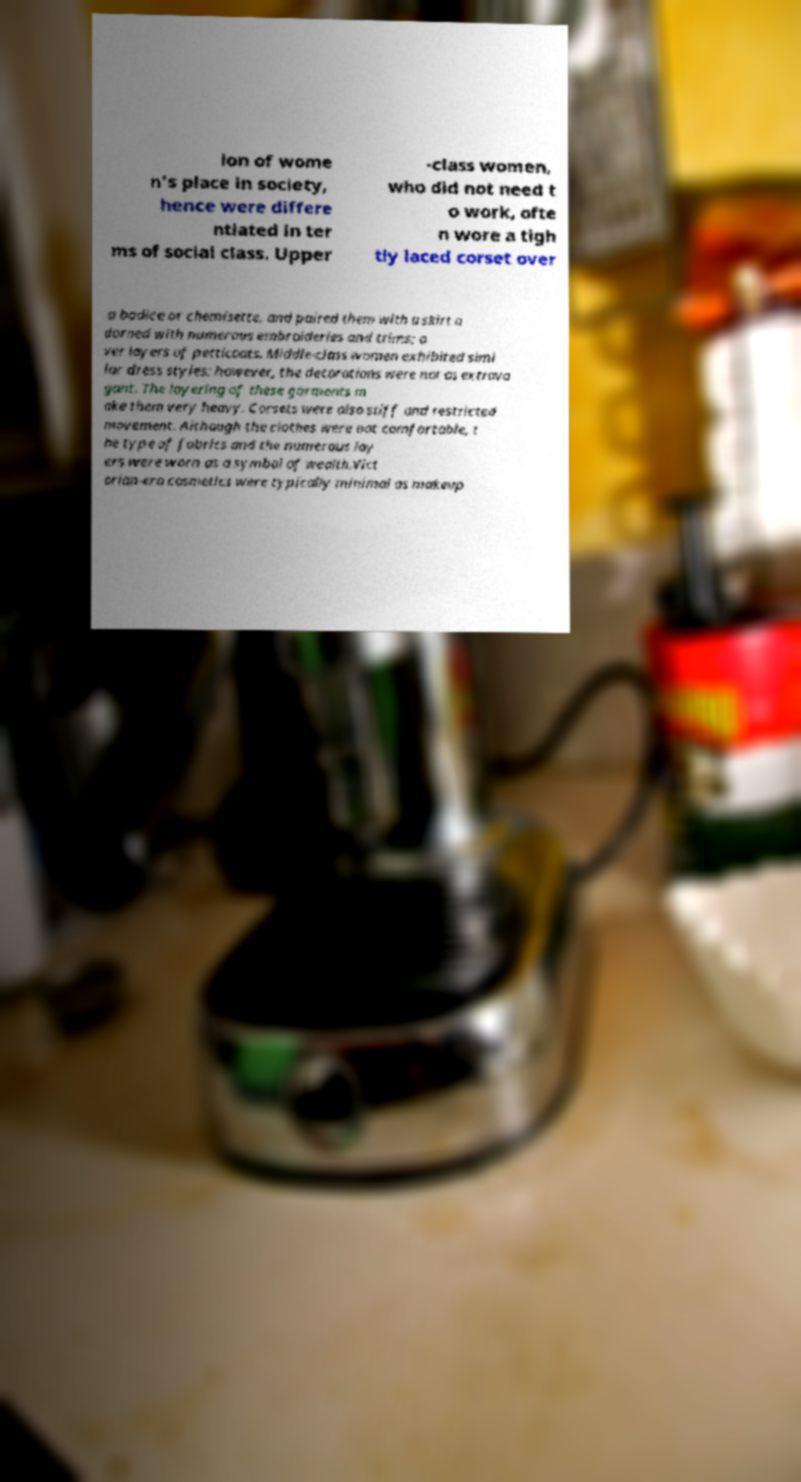For documentation purposes, I need the text within this image transcribed. Could you provide that? ion of wome n's place in society, hence were differe ntiated in ter ms of social class. Upper -class women, who did not need t o work, ofte n wore a tigh tly laced corset over a bodice or chemisette, and paired them with a skirt a dorned with numerous embroideries and trims; o ver layers of petticoats. Middle-class women exhibited simi lar dress styles; however, the decorations were not as extrava gant. The layering of these garments m ake them very heavy. Corsets were also stiff and restricted movement. Although the clothes were not comfortable, t he type of fabrics and the numerous lay ers were worn as a symbol of wealth.Vict orian-era cosmetics were typically minimal as makeup 